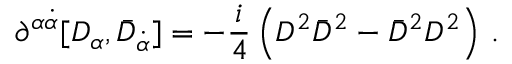Convert formula to latex. <formula><loc_0><loc_0><loc_500><loc_500>\partial ^ { \alpha \dot { \alpha } } [ D _ { \alpha } , \bar { D } _ { \dot { \alpha } } ] = - \frac { i } { 4 } \left ( D ^ { 2 } \bar { D } ^ { 2 } - \bar { D } ^ { 2 } D ^ { 2 } \right ) \, .</formula> 